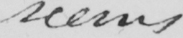Transcribe the text shown in this historical manuscript line. seems 